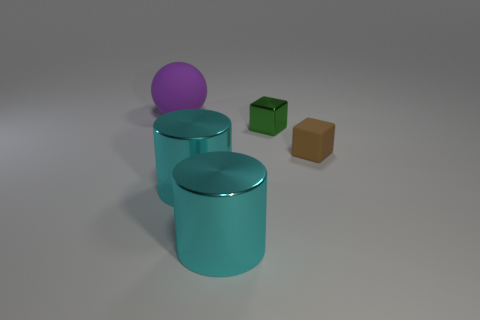What is the size of the block that is on the left side of the brown matte cube?
Ensure brevity in your answer.  Small. Is the shape of the large purple thing the same as the small green thing?
Your answer should be compact. No. There is a metallic thing that is the same shape as the tiny brown rubber thing; what is its color?
Provide a short and direct response. Green. There is a matte thing that is on the right side of the large object that is behind the brown rubber block; what color is it?
Keep it short and to the point. Brown. How many things have the same material as the brown cube?
Ensure brevity in your answer.  1. How many tiny brown blocks are to the left of the tiny metal thing to the left of the brown matte object?
Your answer should be compact. 0. There is a green metallic block; are there any green things to the right of it?
Offer a terse response. No. There is a metal object behind the brown matte cube; does it have the same shape as the purple matte object?
Keep it short and to the point. No. How many tiny rubber things have the same color as the big ball?
Provide a short and direct response. 0. What is the shape of the tiny object that is behind the rubber object that is right of the rubber ball?
Your answer should be very brief. Cube. 